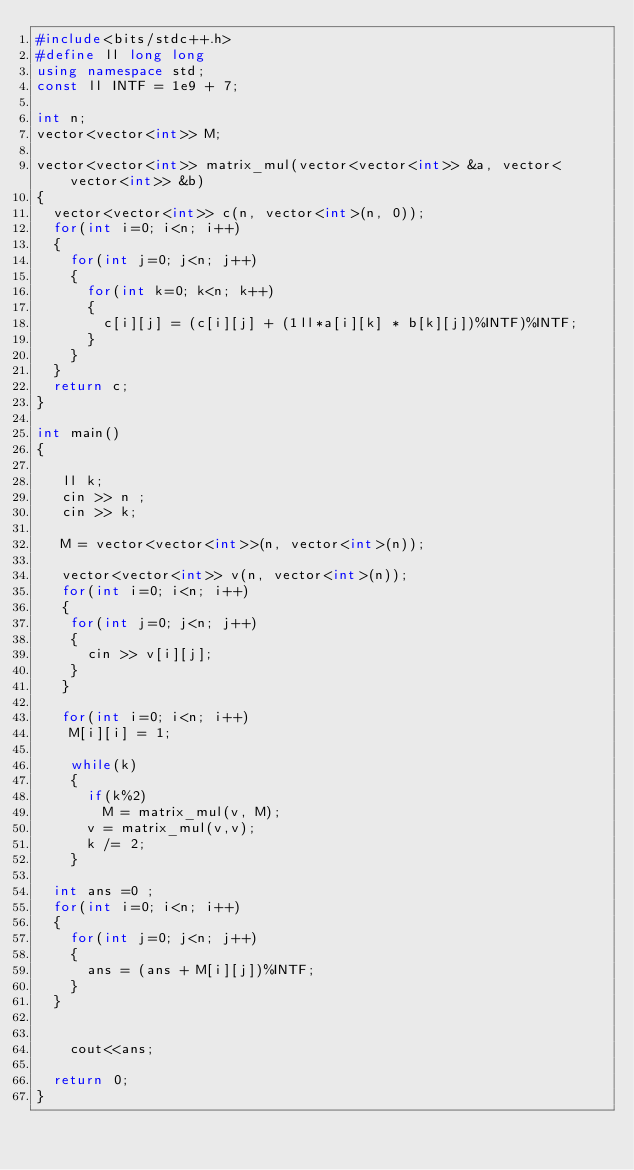Convert code to text. <code><loc_0><loc_0><loc_500><loc_500><_C++_>#include<bits/stdc++.h>
#define ll long long
using namespace std;
const ll INTF = 1e9 + 7;

int n;
vector<vector<int>> M;

vector<vector<int>> matrix_mul(vector<vector<int>> &a, vector<vector<int>> &b)
{
  vector<vector<int>> c(n, vector<int>(n, 0));
  for(int i=0; i<n; i++)
  {
    for(int j=0; j<n; j++)
    {
      for(int k=0; k<n; k++)
      {
        c[i][j] = (c[i][j] + (1ll*a[i][k] * b[k][j])%INTF)%INTF;
      }
    }
  }
  return c;
}

int main()
{

   ll k;
   cin >> n ;
   cin >> k;

   M = vector<vector<int>>(n, vector<int>(n));

   vector<vector<int>> v(n, vector<int>(n));
   for(int i=0; i<n; i++)
   {
    for(int j=0; j<n; j++)
    {
      cin >> v[i][j];
    }
   }

   for(int i=0; i<n; i++)
    M[i][i] = 1;

    while(k)
    {
      if(k%2)
        M = matrix_mul(v, M);
      v = matrix_mul(v,v);
      k /= 2;
    }

  int ans =0 ;
  for(int i=0; i<n; i++)
  {
    for(int j=0; j<n; j++)
    {
      ans = (ans + M[i][j])%INTF;
    }
  }
    

    cout<<ans;

  return 0;
}
</code> 